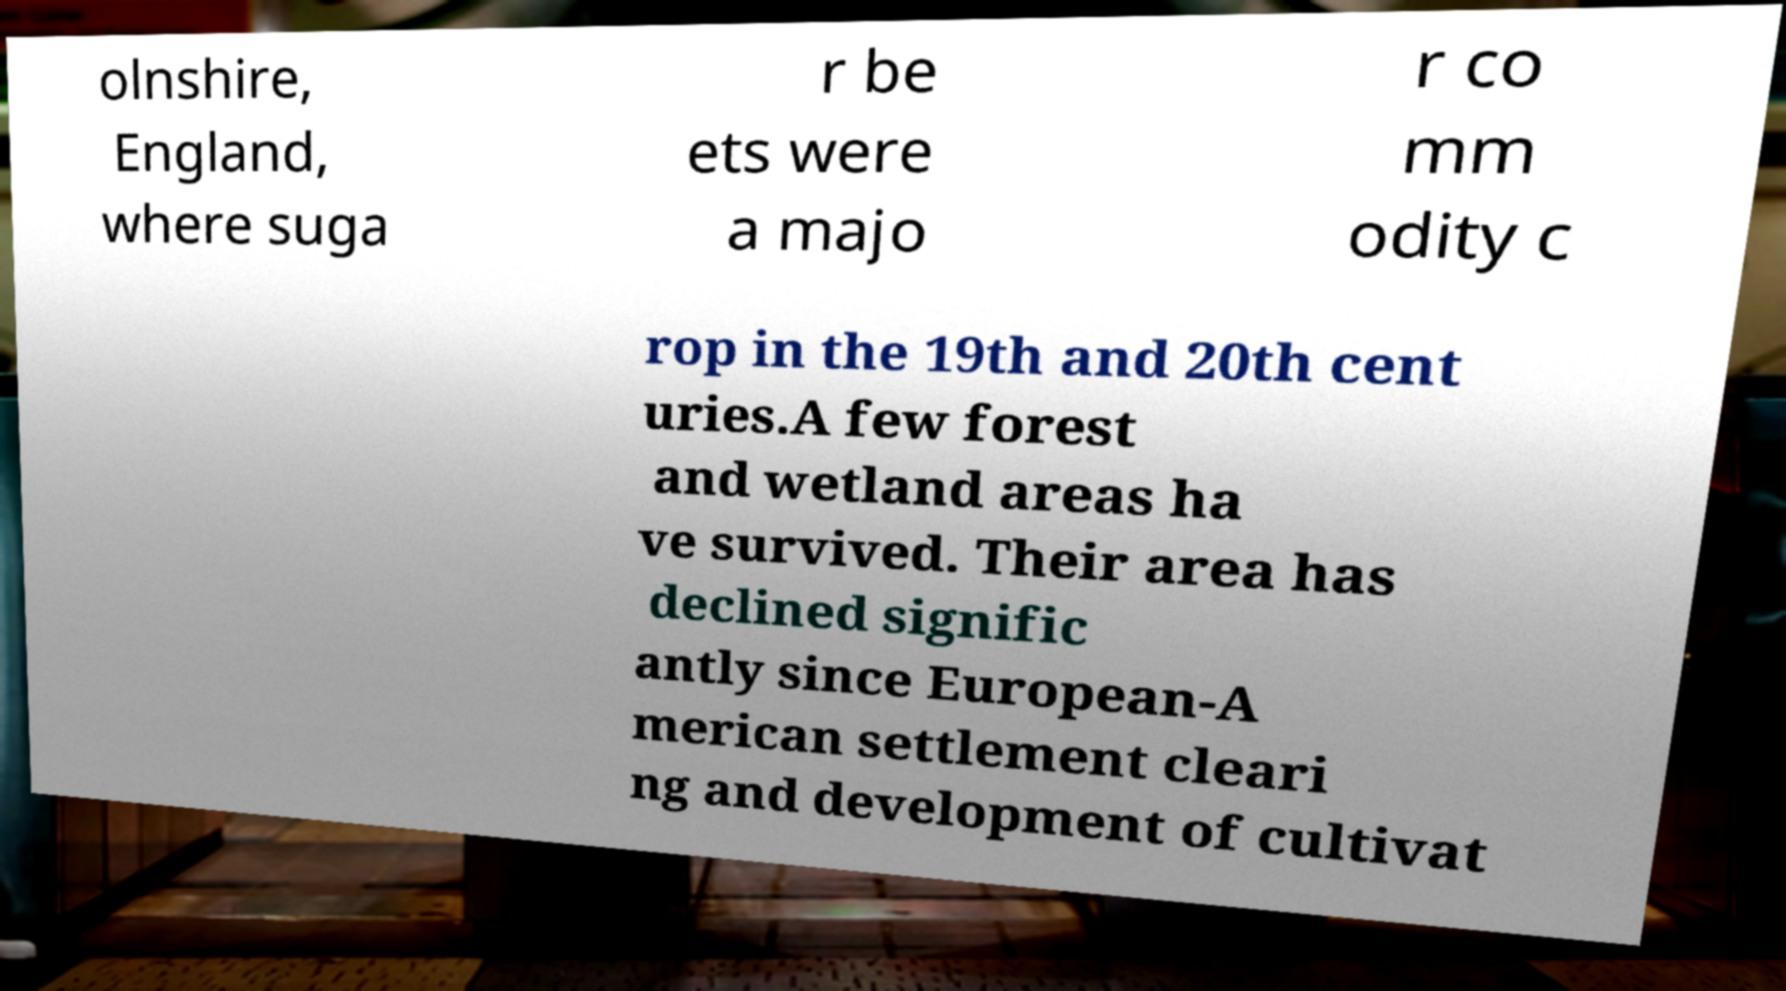For documentation purposes, I need the text within this image transcribed. Could you provide that? olnshire, England, where suga r be ets were a majo r co mm odity c rop in the 19th and 20th cent uries.A few forest and wetland areas ha ve survived. Their area has declined signific antly since European-A merican settlement cleari ng and development of cultivat 